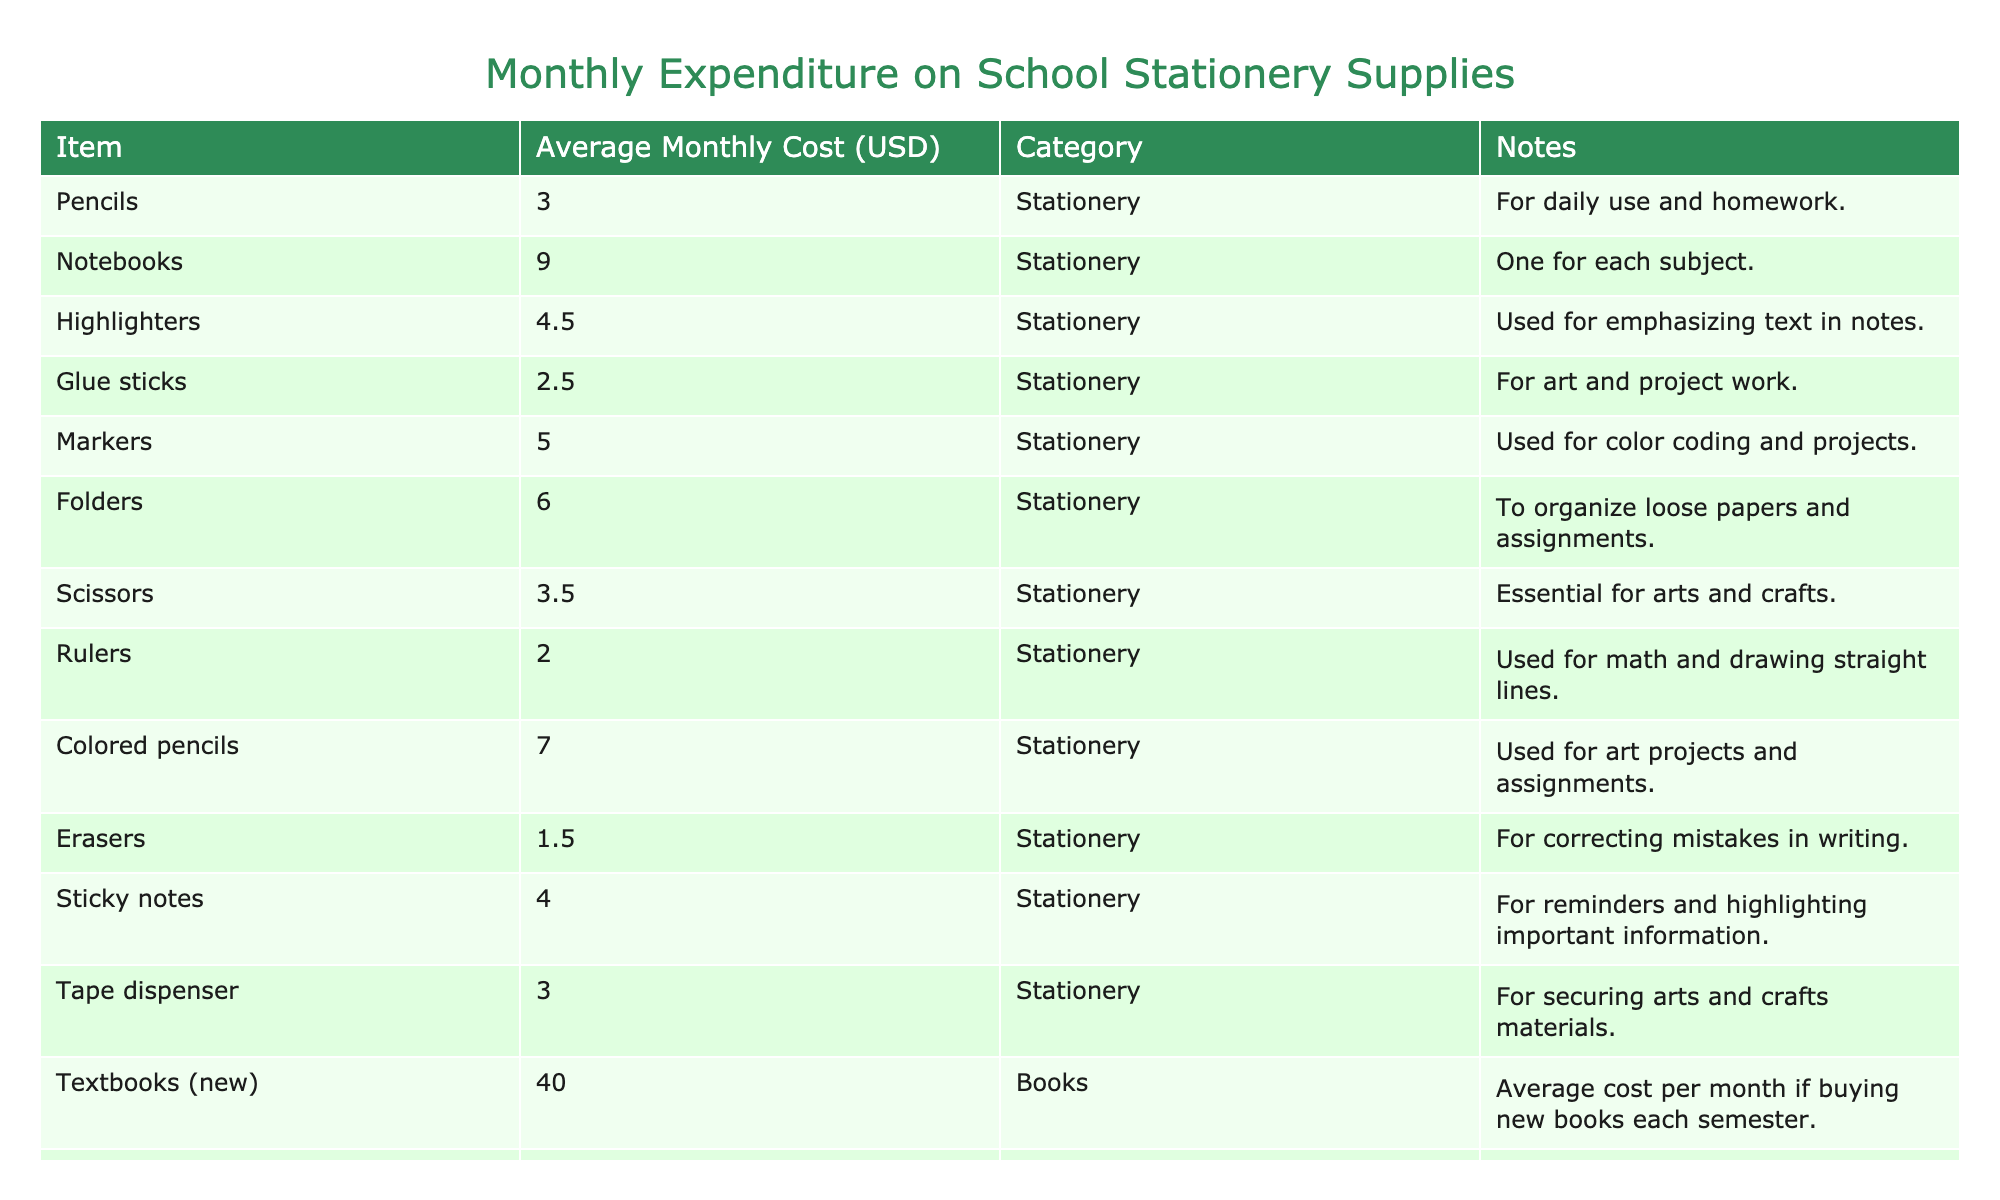What is the average monthly cost of a notebook? The table shows that the average monthly cost of a notebook is listed as 9.00 USD.
Answer: 9.00 USD How much does a pack of highlighters cost compared to a pack of colored pencils? According to the table, highlighters cost 4.50 USD while colored pencils cost 7.00 USD. The difference is 7.00 - 4.50 = 2.50 USD.
Answer: 2.50 USD Is an eraser more expensive than a ruler? The table indicates that an eraser costs 1.50 USD and a ruler costs 2.00 USD. Since 1.50 is less than 2.00, the statement is false.
Answer: No What is the total monthly expenditure on glue sticks and tape dispensers combined? Glue sticks cost 2.50 USD and tape dispensers cost 3.00 USD. Adding them together gives 2.50 + 3.00 = 5.50 USD.
Answer: 5.50 USD How much would it cost to buy 3 notebooks? Each notebook costs 9.00 USD, so for 3 notebooks, the calculation is 3 * 9.00 = 27.00 USD.
Answer: 27.00 USD Are textbooks more expensive than calculators? The average monthly cost of a new textbook is 40.00 USD, while a calculator costs 15.00 USD. Since 40.00 is greater than 15.00, the statement is true.
Answer: Yes Which item has the lowest average monthly cost? Scanning the table for the lowest value, erasers at 1.50 USD is the minimum compared to other items listed.
Answer: Erasers What is the combined cost of all stationery items mentioned in the table? To find the combined cost, sum all stationery items: 3.00 + 9.00 + 4.50 + 2.50 + 5.00 + 6.00 + 3.50 + 2.00 + 7.00 + 1.50 + 4.00 + 3.00 = 46.00 USD.
Answer: 46.00 USD What is the price difference between the most expensive and least expensive item in the stationery category? The most expensive stationery item is colored pencils at 7.00 USD, while the least expensive is erasers at 1.50 USD. The difference is 7.00 - 1.50 = 5.50 USD.
Answer: 5.50 USD 